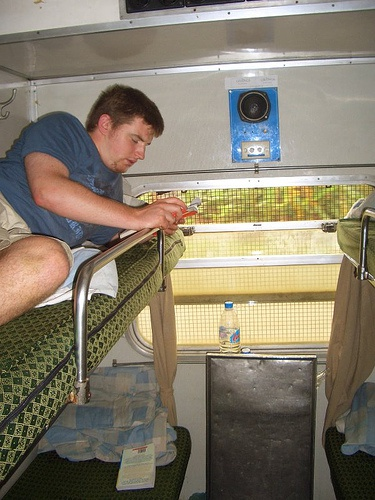Describe the objects in this image and their specific colors. I can see people in gray, salmon, tan, and darkblue tones, bed in gray, black, darkgreen, and olive tones, bed in gray and black tones, bed in gray and black tones, and bottle in gray, khaki, tan, and darkgray tones in this image. 